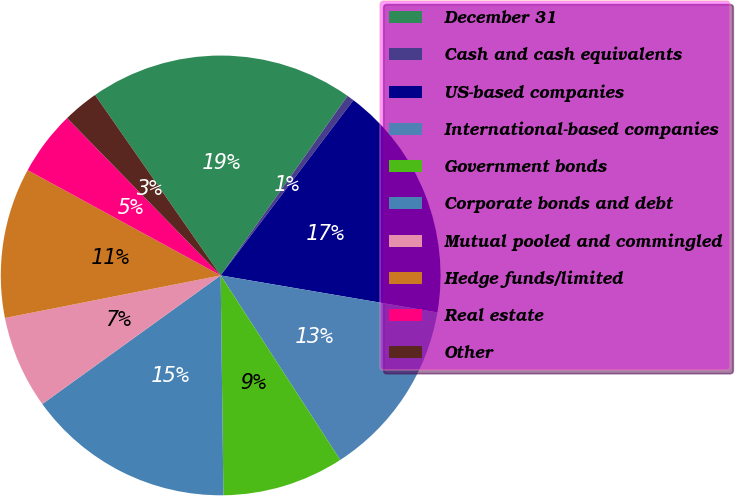<chart> <loc_0><loc_0><loc_500><loc_500><pie_chart><fcel>December 31<fcel>Cash and cash equivalents<fcel>US-based companies<fcel>International-based companies<fcel>Government bonds<fcel>Corporate bonds and debt<fcel>Mutual pooled and commingled<fcel>Hedge funds/limited<fcel>Real estate<fcel>Other<nl><fcel>19.47%<fcel>0.53%<fcel>17.37%<fcel>13.16%<fcel>8.95%<fcel>15.26%<fcel>6.84%<fcel>11.05%<fcel>4.74%<fcel>2.63%<nl></chart> 